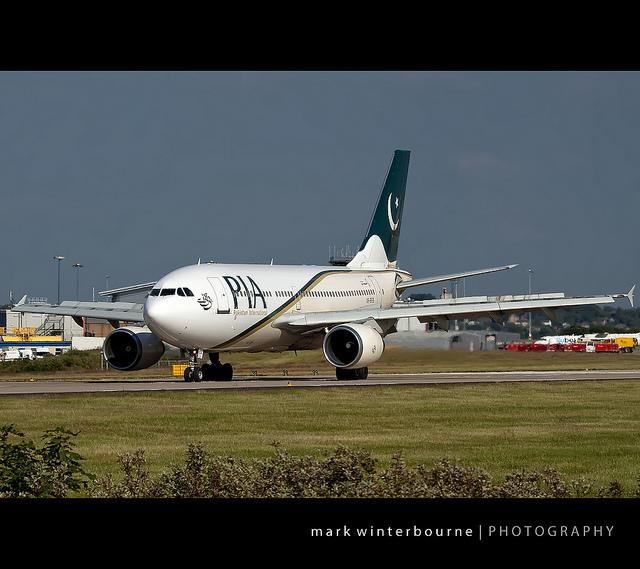What is written on the plane?
Concise answer only. Pia. Is the vehicle shown heavier than a Cessna?
Write a very short answer. Yes. What airline is the plane with?
Give a very brief answer. Pia. 